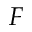Convert formula to latex. <formula><loc_0><loc_0><loc_500><loc_500>F</formula> 